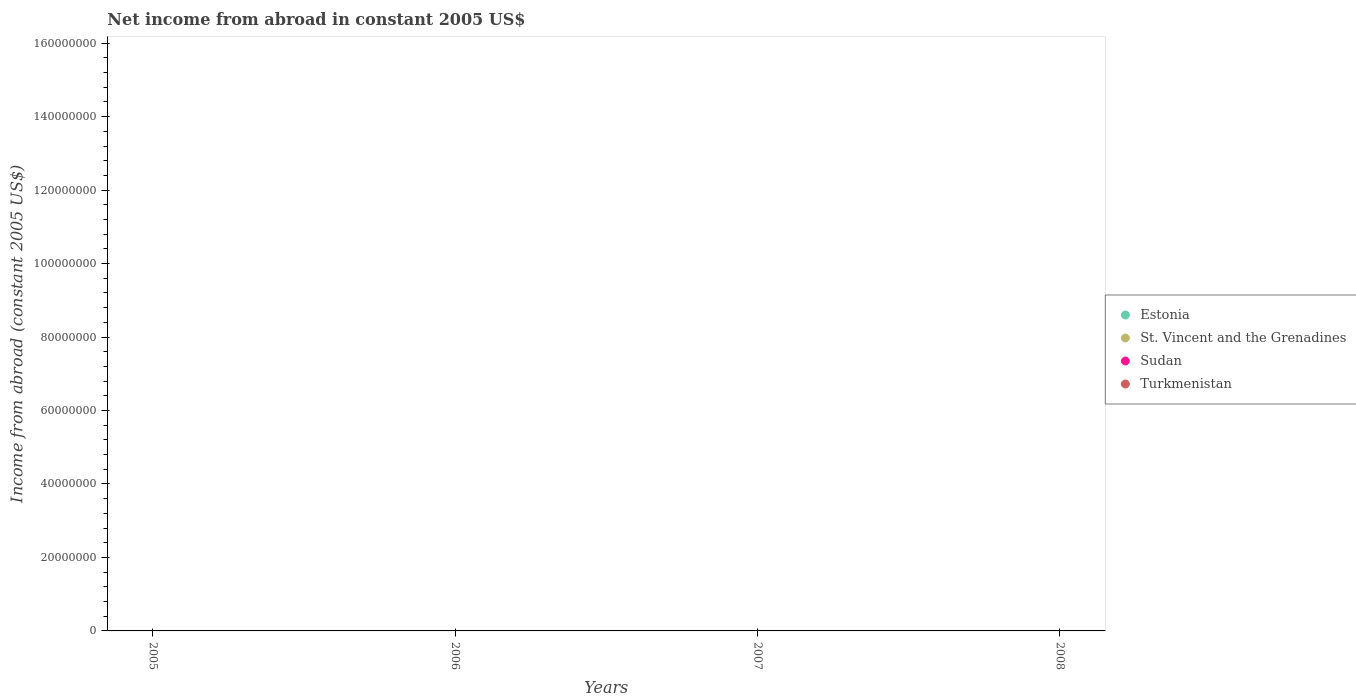How many different coloured dotlines are there?
Make the answer very short. 0. What is the net income from abroad in Sudan in 2007?
Offer a very short reply. 0. Across all years, what is the minimum net income from abroad in Estonia?
Provide a short and direct response. 0. What is the total net income from abroad in Turkmenistan in the graph?
Provide a short and direct response. 0. Is it the case that in every year, the sum of the net income from abroad in Estonia and net income from abroad in Sudan  is greater than the sum of net income from abroad in St. Vincent and the Grenadines and net income from abroad in Turkmenistan?
Ensure brevity in your answer.  No. Does the net income from abroad in Sudan monotonically increase over the years?
Make the answer very short. No. Is the net income from abroad in Turkmenistan strictly greater than the net income from abroad in Sudan over the years?
Give a very brief answer. Yes. Is the net income from abroad in Turkmenistan strictly less than the net income from abroad in Estonia over the years?
Provide a short and direct response. No. How many dotlines are there?
Make the answer very short. 0. How many years are there in the graph?
Your response must be concise. 4. What is the difference between two consecutive major ticks on the Y-axis?
Offer a very short reply. 2.00e+07. Are the values on the major ticks of Y-axis written in scientific E-notation?
Provide a short and direct response. No. Does the graph contain any zero values?
Offer a terse response. Yes. How many legend labels are there?
Keep it short and to the point. 4. What is the title of the graph?
Your answer should be very brief. Net income from abroad in constant 2005 US$. What is the label or title of the Y-axis?
Your response must be concise. Income from abroad (constant 2005 US$). What is the Income from abroad (constant 2005 US$) of Sudan in 2005?
Offer a very short reply. 0. What is the Income from abroad (constant 2005 US$) of Turkmenistan in 2005?
Give a very brief answer. 0. What is the Income from abroad (constant 2005 US$) of Estonia in 2006?
Ensure brevity in your answer.  0. What is the Income from abroad (constant 2005 US$) of Sudan in 2006?
Your answer should be compact. 0. What is the Income from abroad (constant 2005 US$) of Estonia in 2007?
Keep it short and to the point. 0. What is the Income from abroad (constant 2005 US$) of Sudan in 2007?
Your answer should be compact. 0. What is the Income from abroad (constant 2005 US$) of Turkmenistan in 2007?
Your answer should be compact. 0. What is the Income from abroad (constant 2005 US$) in Estonia in 2008?
Ensure brevity in your answer.  0. What is the Income from abroad (constant 2005 US$) of Sudan in 2008?
Offer a terse response. 0. What is the Income from abroad (constant 2005 US$) of Turkmenistan in 2008?
Offer a terse response. 0. What is the total Income from abroad (constant 2005 US$) of Estonia in the graph?
Make the answer very short. 0. What is the total Income from abroad (constant 2005 US$) in St. Vincent and the Grenadines in the graph?
Your answer should be compact. 0. What is the total Income from abroad (constant 2005 US$) in Turkmenistan in the graph?
Your answer should be compact. 0. What is the average Income from abroad (constant 2005 US$) of Estonia per year?
Offer a terse response. 0. 